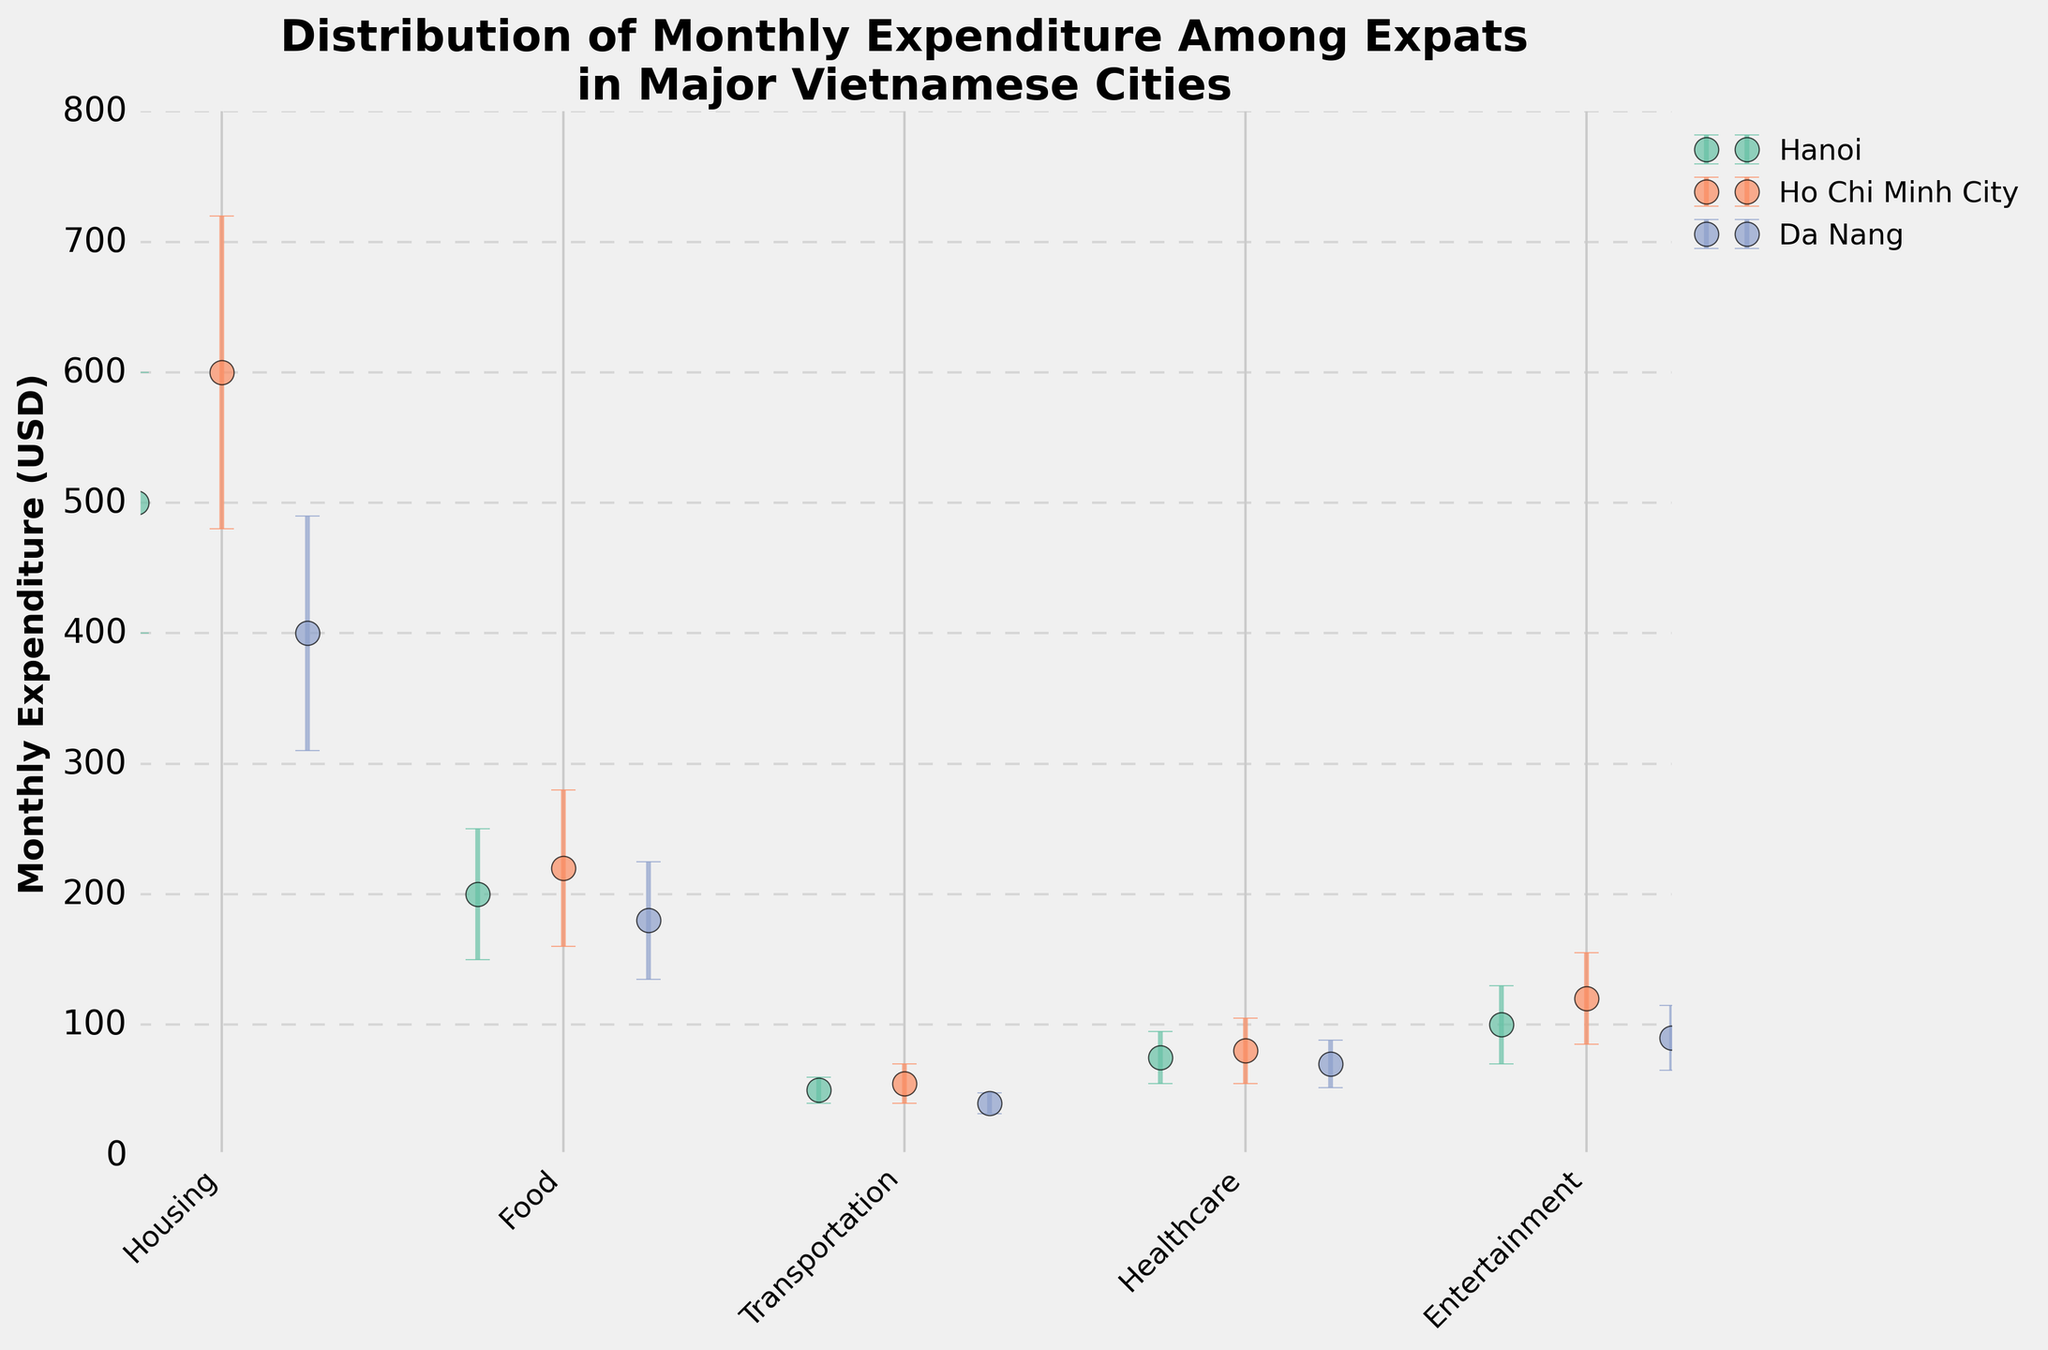What's the average monthly expenditure on Food in Ho Chi Minh City? The mean expenditure on Food in Ho Chi Minh City is given as $220. This value can be directly read from the figure.
Answer: 220 USD Which city has the highest mean expenditure on Entertainment? By comparing the mean expenditures on Entertainment across all cities, it's evident that Ho Chi Minh City has the highest value of $120.
Answer: Ho Chi Minh City How do the standard deviations in Housing expenditure compare between Hanoi and Da Nang? The standard deviation for Housing in Hanoi is $100 while in Da Nang it is $90. Therefore, Hanoi has a slightly larger standard deviation for Housing.
Answer: Hanoi > Da Nang What is the total mean expenditure on Transportation across all cities? Summing the mean expenditures on Transportation: (Hanoi: $50) + (Ho Chi Minh City: $55) + (Da Nang: $40) gives $145 as the total mean expenditure on Transportation across all cities.
Answer: 145 USD How much greater is the mean expenditure on Healthcare in Ho Chi Minh City compared to Da Nang? The mean expenditure on Healthcare in Ho Chi Minh City is $80 and in Da Nang, it is $70. The difference is $80 - $70 = $10.
Answer: 10 USD Which city has the smallest standard deviation for Entertainment expenditure? Comparing the standard deviations for Entertainment, Hanoi has the smallest standard deviation ($30).
Answer: Hanoi Which category has the highest mean expenditure in all cities? By comparing mean expenditures across all categories and cities, Housing in Ho Chi Minh City has the highest mean expenditure of $600.
Answer: Housing in Ho Chi Minh City For Hanoi, which expenditure category has the largest standard deviation? By comparing the standard deviations within Hanoi, Housing has the largest standard deviation of $100.
Answer: Housing Is the mean expenditure on Food in Da Nang higher or lower than in Hanoi? The mean expenditure on Food in Da Nang is $180, which is lower compared to $200 in Hanoi.
Answer: Lower What is the range of the mean monthly expenditure on Food across all cities? The mean expenditures on Food are $200 in Hanoi, $220 in Ho Chi Minh City, and $180 in Da Nang. The range is calculated as the difference between the maximum and minimum values: $220 - $180 = $40.
Answer: 40 USD 